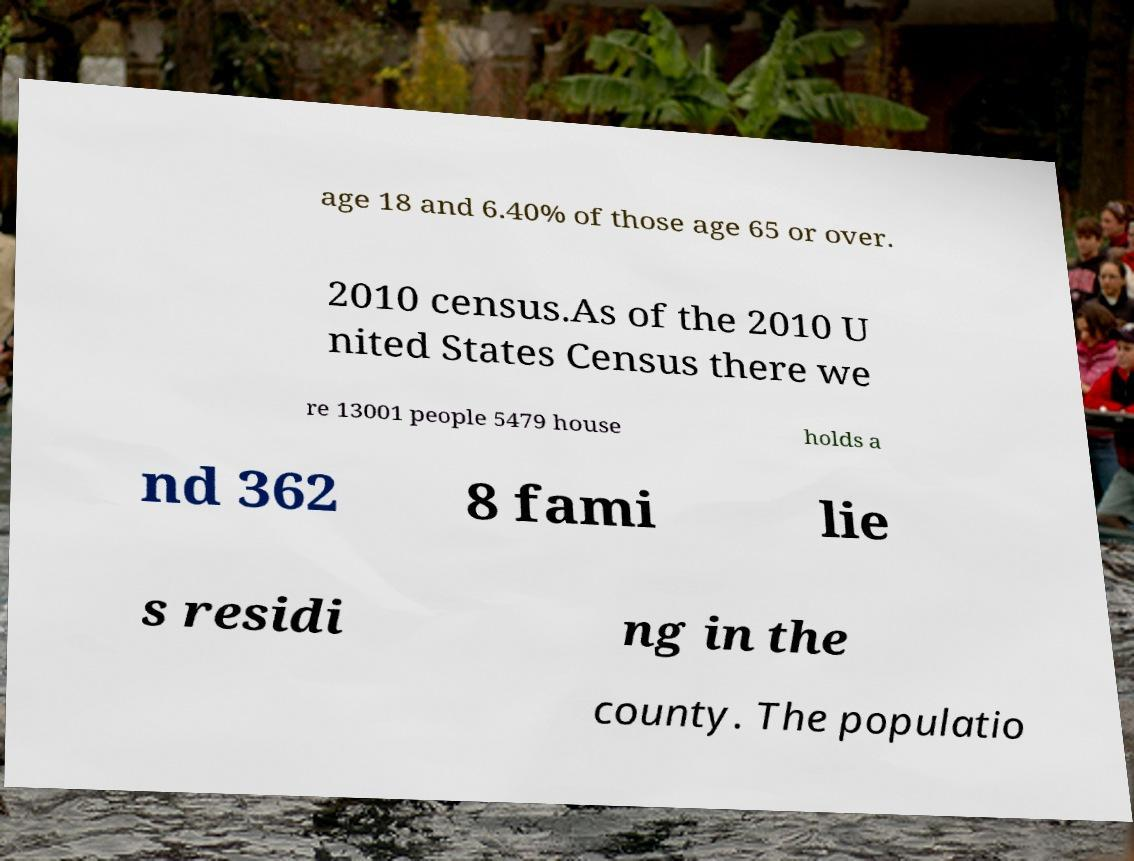There's text embedded in this image that I need extracted. Can you transcribe it verbatim? age 18 and 6.40% of those age 65 or over. 2010 census.As of the 2010 U nited States Census there we re 13001 people 5479 house holds a nd 362 8 fami lie s residi ng in the county. The populatio 